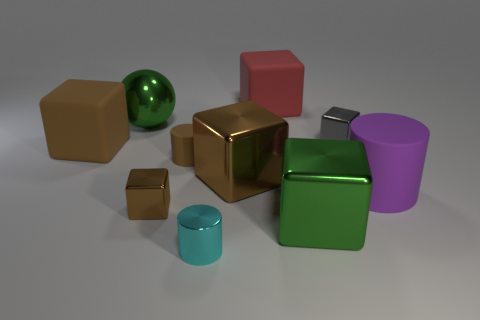What is the shape of the gray shiny thing that is the same size as the shiny cylinder?
Your response must be concise. Cube. How many other things are there of the same color as the sphere?
Ensure brevity in your answer.  1. What number of gray things are small cubes or metallic blocks?
Ensure brevity in your answer.  1. There is a big matte object in front of the big brown matte block; does it have the same shape as the green thing that is in front of the large green shiny ball?
Offer a very short reply. No. What number of other objects are there of the same material as the brown cylinder?
Provide a succinct answer. 3. There is a rubber cube behind the green shiny object that is on the left side of the red object; are there any large rubber objects that are right of it?
Offer a terse response. Yes. Is the material of the big purple object the same as the tiny cyan object?
Your answer should be very brief. No. Is there anything else that has the same shape as the big brown metallic thing?
Your answer should be very brief. Yes. The big brown thing that is left of the shiny cube that is left of the metal cylinder is made of what material?
Make the answer very short. Rubber. There is a green metal thing right of the green ball; what is its size?
Your answer should be compact. Large. 